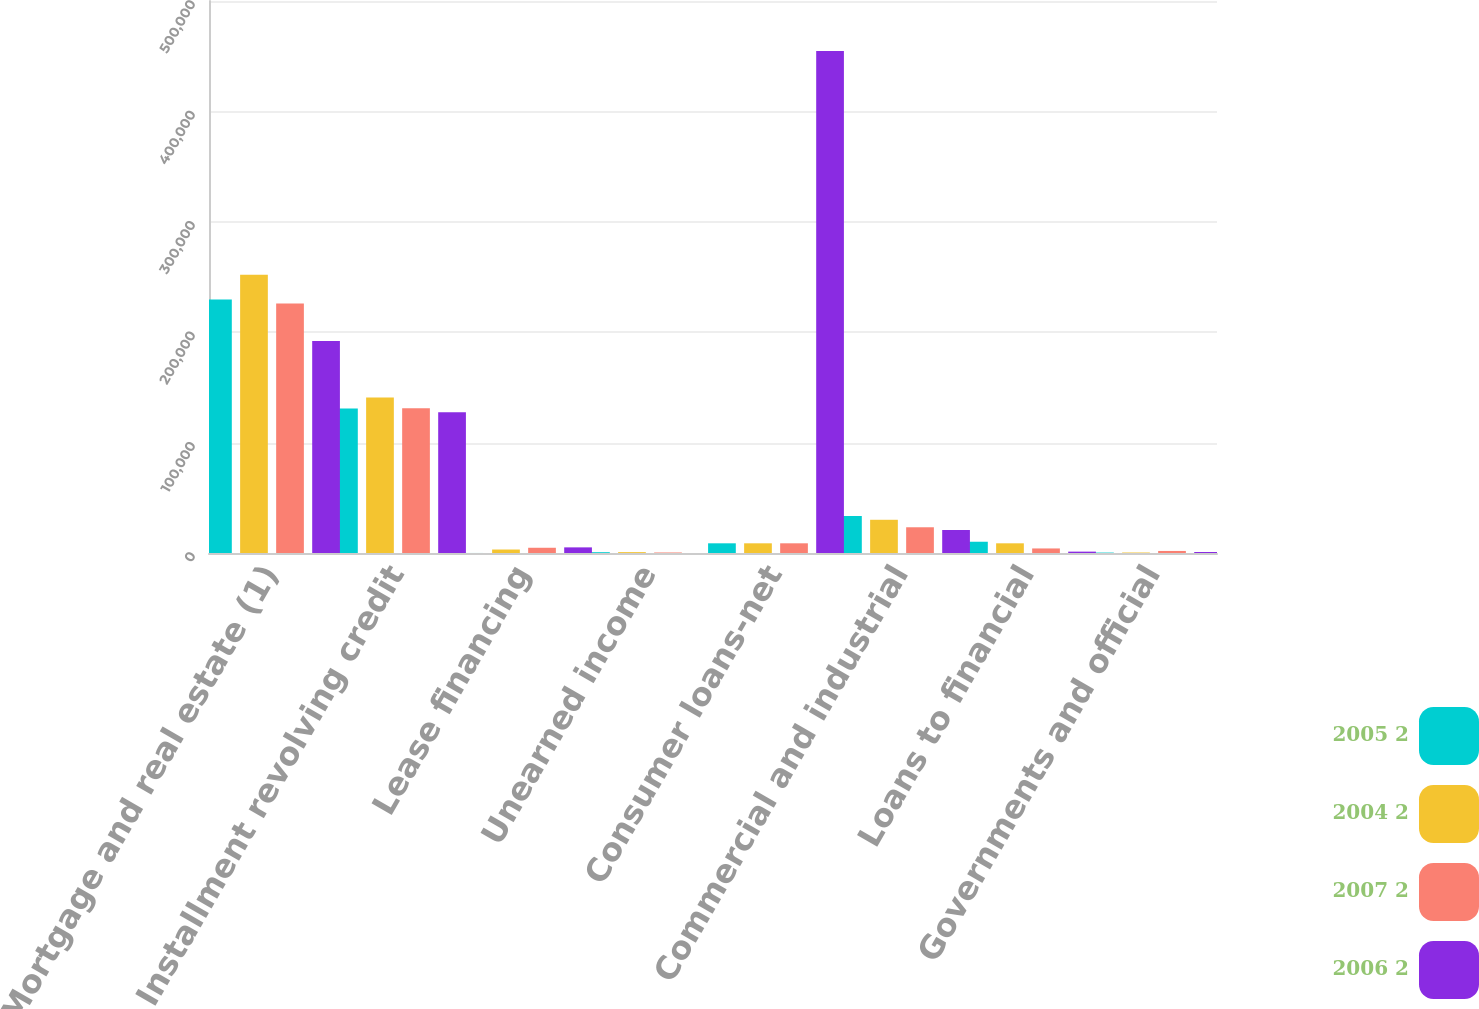Convert chart. <chart><loc_0><loc_0><loc_500><loc_500><stacked_bar_chart><ecel><fcel>Mortgage and real estate (1)<fcel>Installment revolving credit<fcel>Lease financing<fcel>Unearned income<fcel>Consumer loans-net<fcel>Commercial and industrial<fcel>Loans to financial<fcel>Governments and official<nl><fcel>2005 2<fcel>229565<fcel>130826<fcel>31<fcel>738<fcel>8778<fcel>33450<fcel>10200<fcel>385<nl><fcel>2004 2<fcel>251927<fcel>140797<fcel>3151<fcel>787<fcel>8778<fcel>30092<fcel>8778<fcel>442<nl><fcel>2007 2<fcel>225900<fcel>131008<fcel>4743<fcel>460<fcel>8778<fcel>23311<fcel>4126<fcel>1857<nl><fcel>2006 2<fcel>192045<fcel>127432<fcel>5095<fcel>4<fcel>454620<fcel>20846<fcel>1235<fcel>882<nl></chart> 